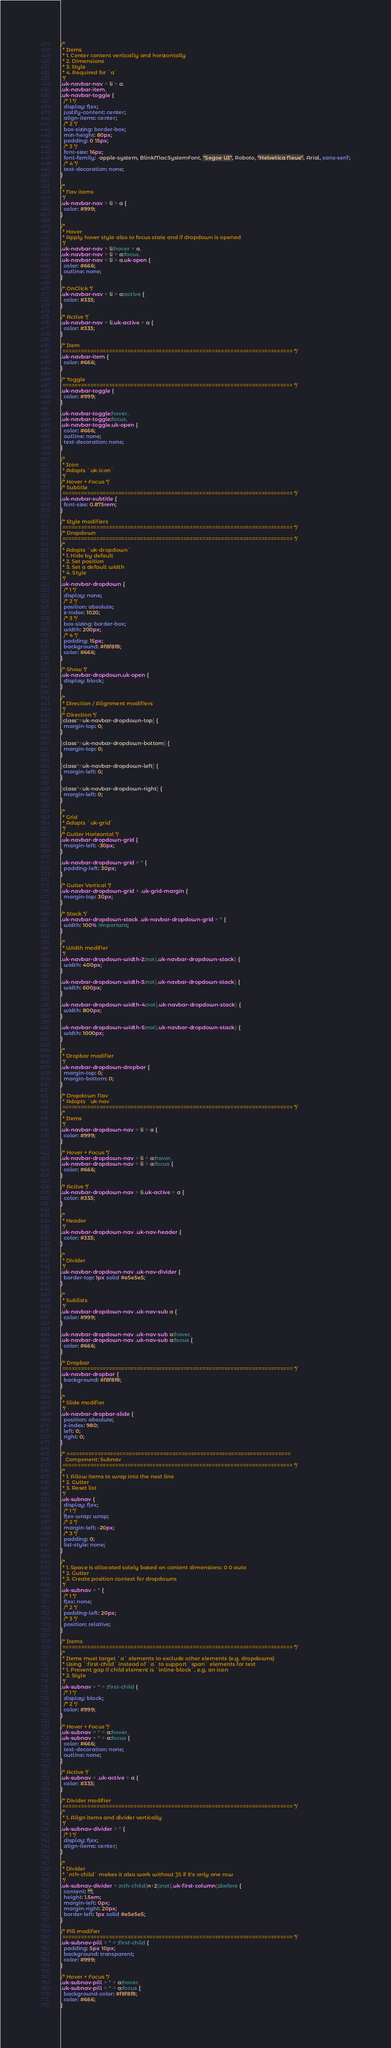<code> <loc_0><loc_0><loc_500><loc_500><_CSS_>/*
 * Items
 * 1. Center content vertically and horizontally
 * 2. Dimensions
 * 3. Style
 * 4. Required for `a`
 */
.uk-navbar-nav > li > a,
.uk-navbar-item,
.uk-navbar-toggle {
  /* 1 */
  display: flex;
  justify-content: center;
  align-items: center;
  /* 2 */
  box-sizing: border-box;
  min-height: 80px;
  padding: 0 15px;
  /* 3 */
  font-size: 16px;
  font-family: -apple-system, BlinkMacSystemFont, "Segoe UI", Roboto, "Helvetica Neue", Arial, sans-serif;
  /* 4 */
  text-decoration: none;
}

/*
 * Nav items
 */
.uk-navbar-nav > li > a {
  color: #999;
}

/*
 * Hover
 * Apply hover style also to focus state and if dropdown is opened
 */
.uk-navbar-nav > li:hover > a,
.uk-navbar-nav > li > a:focus,
.uk-navbar-nav > li > a.uk-open {
  color: #666;
  outline: none;
}

/* OnClick */
.uk-navbar-nav > li > a:active {
  color: #333;
}

/* Active */
.uk-navbar-nav > li.uk-active > a {
  color: #333;
}

/* Item
 ========================================================================== */
.uk-navbar-item {
  color: #666;
}

/* Toggle
 ========================================================================== */
.uk-navbar-toggle {
  color: #999;
}

.uk-navbar-toggle:hover,
.uk-navbar-toggle:focus,
.uk-navbar-toggle.uk-open {
  color: #666;
  outline: none;
  text-decoration: none;
}

/*
 * Icon
 * Adopts `uk-icon`
 */
/* Hover + Focus */
/* Subtitle
 ========================================================================== */
.uk-navbar-subtitle {
  font-size: 0.875rem;
}

/* Style modifiers
 ========================================================================== */
/* Dropdown
 ========================================================================== */
/*
 * Adopts `uk-dropdown`
 * 1. Hide by default
 * 2. Set position
 * 3. Set a default width
 * 4. Style
 */
.uk-navbar-dropdown {
  /* 1 */
  display: none;
  /* 2 */
  position: absolute;
  z-index: 1020;
  /* 3 */
  box-sizing: border-box;
  width: 200px;
  /* 4 */
  padding: 15px;
  background: #f8f8f8;
  color: #666;
}

/* Show */
.uk-navbar-dropdown.uk-open {
  display: block;
}

/*
 * Direction / Alignment modifiers
 */
/* Direction */
[class*=uk-navbar-dropdown-top] {
  margin-top: 0;
}

[class*=uk-navbar-dropdown-bottom] {
  margin-top: 0;
}

[class*=uk-navbar-dropdown-left] {
  margin-left: 0;
}

[class*=uk-navbar-dropdown-right] {
  margin-left: 0;
}

/*
 * Grid
 * Adopts `uk-grid`
 */
/* Gutter Horizontal */
.uk-navbar-dropdown-grid {
  margin-left: -30px;
}

.uk-navbar-dropdown-grid > * {
  padding-left: 30px;
}

/* Gutter Vertical */
.uk-navbar-dropdown-grid > .uk-grid-margin {
  margin-top: 30px;
}

/* Stack */
.uk-navbar-dropdown-stack .uk-navbar-dropdown-grid > * {
  width: 100% !important;
}

/*
 * Width modifier
 */
.uk-navbar-dropdown-width-2:not(.uk-navbar-dropdown-stack) {
  width: 400px;
}

.uk-navbar-dropdown-width-3:not(.uk-navbar-dropdown-stack) {
  width: 600px;
}

.uk-navbar-dropdown-width-4:not(.uk-navbar-dropdown-stack) {
  width: 800px;
}

.uk-navbar-dropdown-width-5:not(.uk-navbar-dropdown-stack) {
  width: 1000px;
}

/*
 * Dropbar modifier
 */
.uk-navbar-dropdown-dropbar {
  margin-top: 0;
  margin-bottom: 0;
}

/* Dropdown Nav
 * Adopts `uk-nav`
 ========================================================================== */
/*
 * Items
 */
.uk-navbar-dropdown-nav > li > a {
  color: #999;
}

/* Hover + Focus */
.uk-navbar-dropdown-nav > li > a:hover,
.uk-navbar-dropdown-nav > li > a:focus {
  color: #666;
}

/* Active */
.uk-navbar-dropdown-nav > li.uk-active > a {
  color: #333;
}

/*
 * Header
 */
.uk-navbar-dropdown-nav .uk-nav-header {
  color: #333;
}

/*
 * Divider
 */
.uk-navbar-dropdown-nav .uk-nav-divider {
  border-top: 1px solid #e5e5e5;
}

/*
 * Sublists
 */
.uk-navbar-dropdown-nav .uk-nav-sub a {
  color: #999;
}

.uk-navbar-dropdown-nav .uk-nav-sub a:hover,
.uk-navbar-dropdown-nav .uk-nav-sub a:focus {
  color: #666;
}

/* Dropbar
 ========================================================================== */
.uk-navbar-dropbar {
  background: #f8f8f8;
}

/*
 * Slide modifier
 */
.uk-navbar-dropbar-slide {
  position: absolute;
  z-index: 980;
  left: 0;
  right: 0;
}

/* ========================================================================
   Component: Subnav
 ========================================================================== */
/*
 * 1. Allow items to wrap into the next line
 * 2. Gutter
 * 3. Reset list
 */
.uk-subnav {
  display: flex;
  /* 1 */
  flex-wrap: wrap;
  /* 2 */
  margin-left: -20px;
  /* 3 */
  padding: 0;
  list-style: none;
}

/*
 * 1. Space is allocated solely based on content dimensions: 0 0 auto
 * 2. Gutter
 * 3. Create position context for dropdowns
 */
.uk-subnav > * {
  /* 1 */
  flex: none;
  /* 2 */
  padding-left: 20px;
  /* 3 */
  position: relative;
}

/* Items
 ========================================================================== */
/*
 * Items must target `a` elements to exclude other elements (e.g. dropdowns)
 * Using `:first-child` instead of `a` to support `span` elements for text
 * 1. Prevent gap if child element is `inline-block`, e.g. an icon
 * 2. Style
 */
.uk-subnav > * > :first-child {
  /* 1 */
  display: block;
  /* 2 */
  color: #999;
}

/* Hover + Focus */
.uk-subnav > * > a:hover,
.uk-subnav > * > a:focus {
  color: #666;
  text-decoration: none;
  outline: none;
}

/* Active */
.uk-subnav > .uk-active > a {
  color: #333;
}

/* Divider modifier
 ========================================================================== */
/*
 * 1. Align items and divider vertically
 */
.uk-subnav-divider > * {
  /* 1 */
  display: flex;
  align-items: center;
}

/*
 * Divider
 * `nth-child` makes it also work without JS if it's only one row
 */
.uk-subnav-divider > :nth-child(n+2):not(.uk-first-column)::before {
  content: "";
  height: 1.5em;
  margin-left: 0px;
  margin-right: 20px;
  border-left: 1px solid #e5e5e5;
}

/* Pill modifier
 ========================================================================== */
.uk-subnav-pill > * > :first-child {
  padding: 5px 10px;
  background: transparent;
  color: #999;
}

/* Hover + Focus */
.uk-subnav-pill > * > a:hover,
.uk-subnav-pill > * > a:focus {
  background-color: #f8f8f8;
  color: #666;
}
</code> 